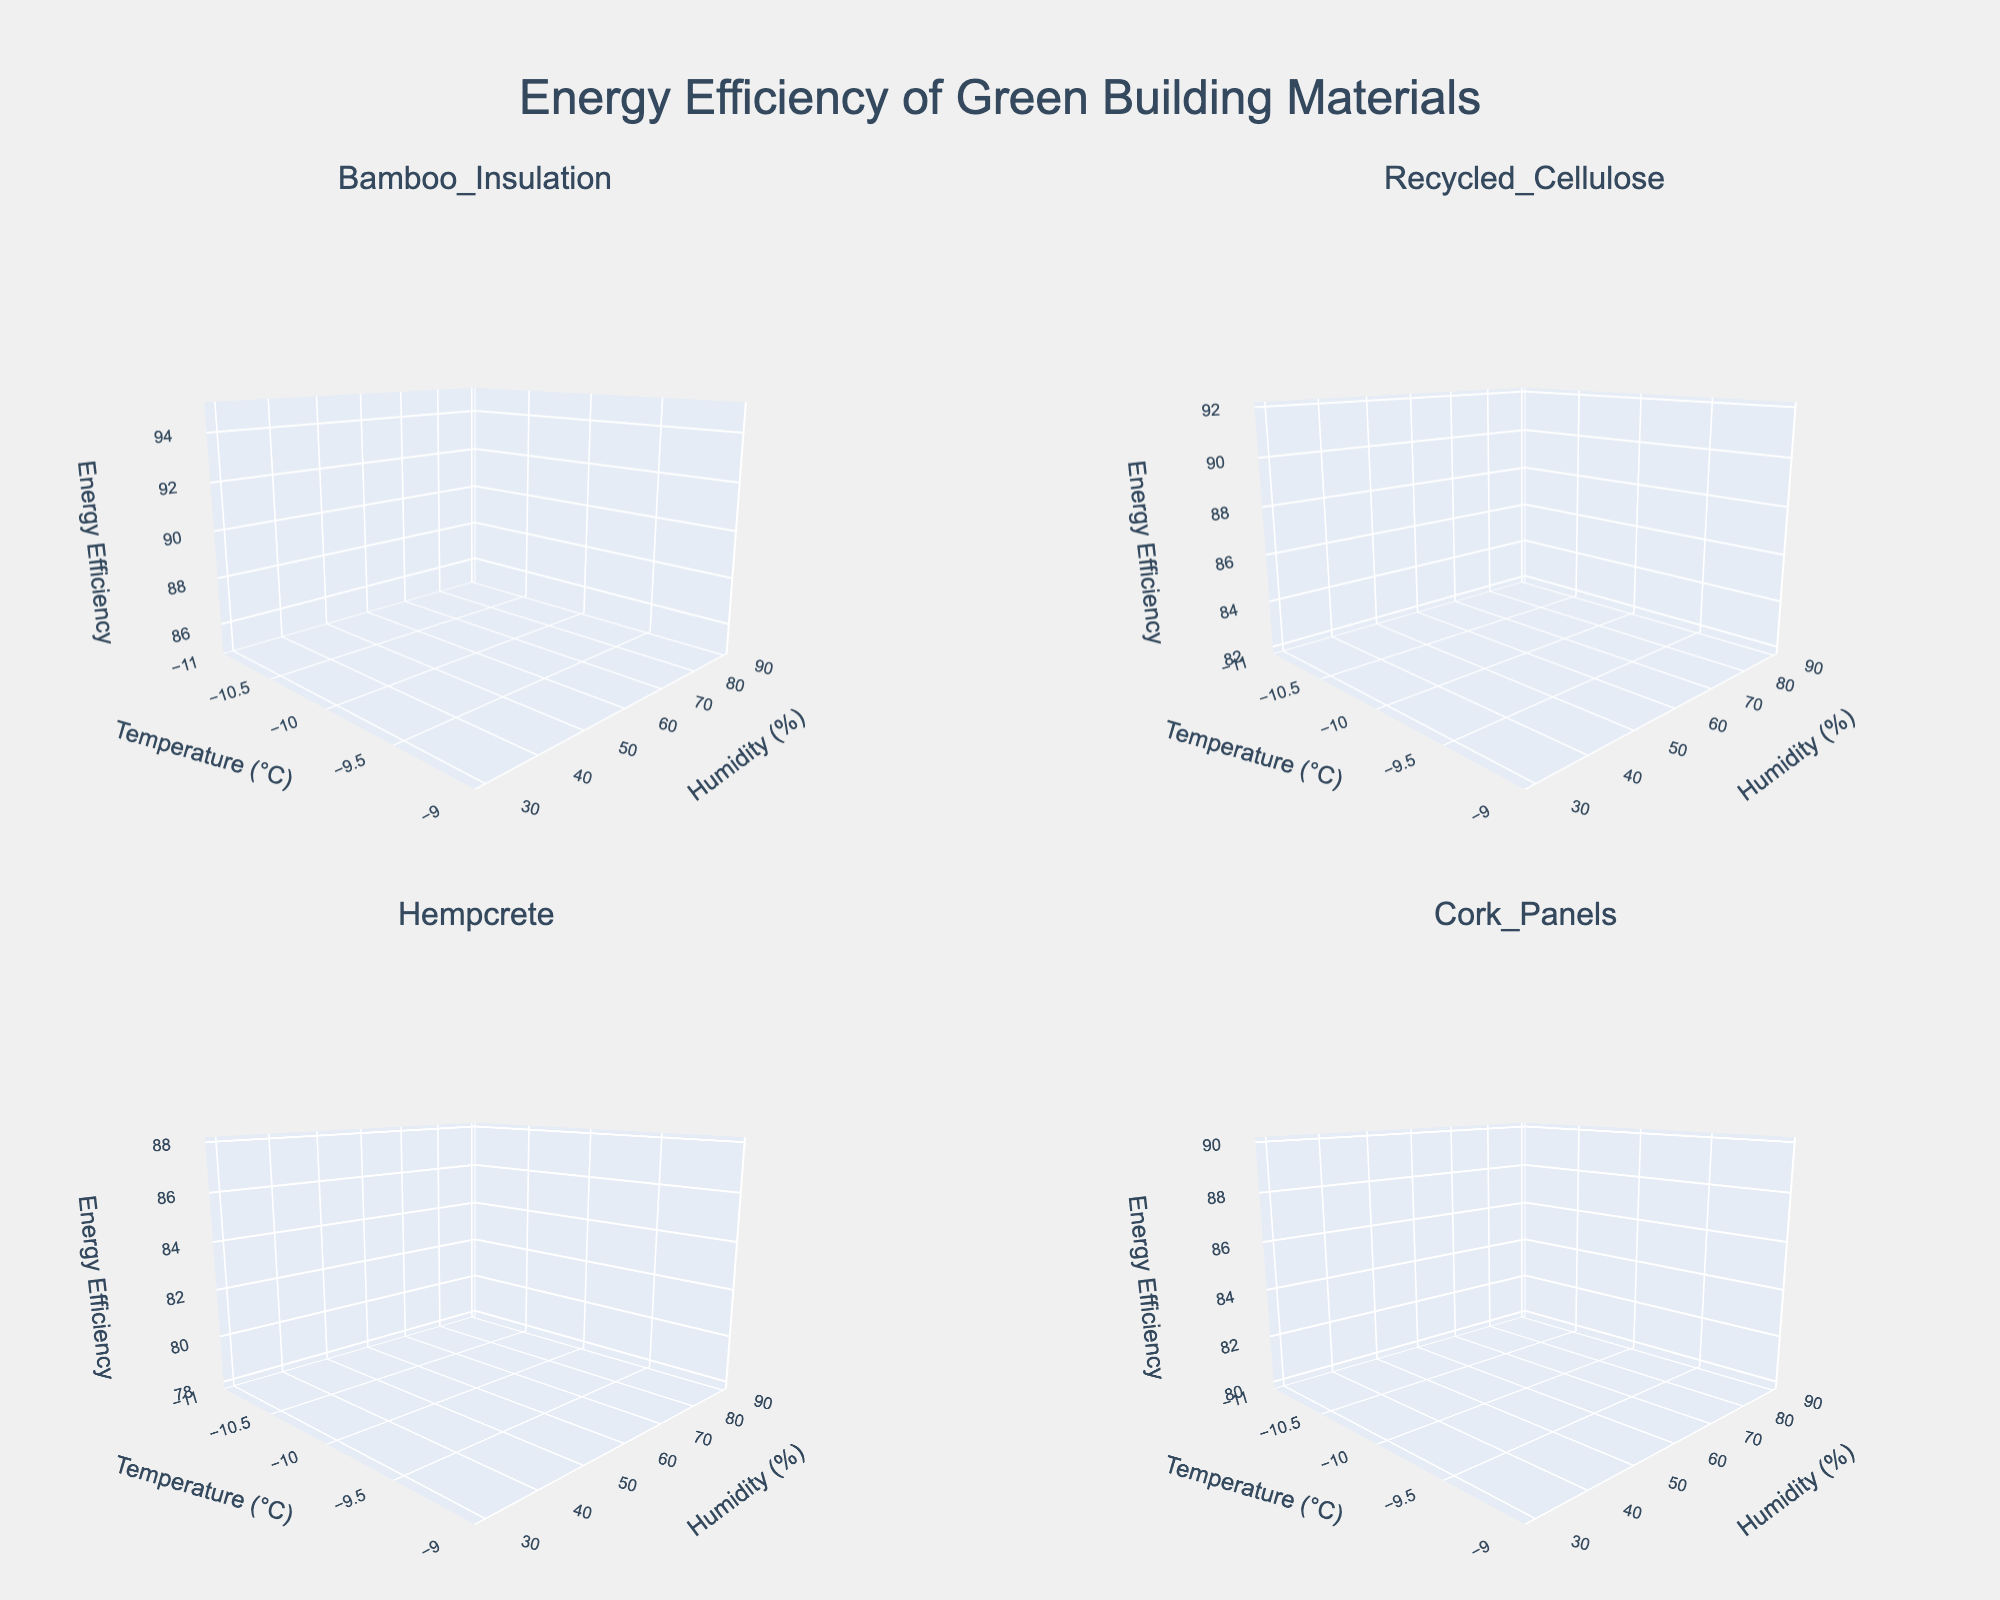What is the title of the figure? The title is typically displayed at the top of a figure and summarizes the main focus of the visualization. According to the code, the title of the figure is "Energy Efficiency of Green Building Materials."
Answer: Energy Efficiency of Green Building Materials Which material shows the highest energy efficiency at 20°C and 30% humidity? First, look at the subplot titles to locate the subplot for each material. Then, find the energy efficiency values at 20°C and 30% humidity. Bamboo Insulation has the highest energy efficiency at this condition, registering 95 in its subplot.
Answer: Bamboo Insulation How does the energy efficiency of Recycled Cellulose change as humidity increases from 30% to 90% at 20°C? Examine the subplot for Recycled Cellulose to determine the energy efficiency at various humidity levels. The values are 92, 89, 86, and 83 as humidity increases from 30% to 90%.
Answer: Decreases Compare the energy efficiency of Hempcrete and Cork Panels at 20°C and 50% humidity. Which is more efficient? Locate the subplots for Hempcrete and Cork Panels and find the energy efficiency values at 20°C and 50% humidity. Both materials have the same energy efficiency of 86 at this condition.
Answer: Both are equal Which subplots show a decline in energy efficiency as the temperature increases from 20°C to 30°C at 30% humidity? Check each subplot for the values at 20°C and 30°C and 30% humidity. Bamboo Insulation and Hempcrete both decline (95 to 93 and 88 to 86, respectively).
Answer: Bamboo Insulation and Hempcrete If we average the energy efficiency values at -10°C across all humidity levels, which material is most efficient? Identify the energy efficiency values at -10°C for each humidity level in each subplot. For Bamboo Insulation (-10°C: 85), Recycled Cellulose (-10°C: 82), Hempcrete (-10°C: 78), and Cork Panels (-10°C: 80). Calculate the averages; Bamboo Insulation has the highest value.
Answer: Bamboo Insulation What trend is observed in Cork Panels' energy efficiency as temperature increases from -10°C to 20°C at 30% humidity? Follow Cork Panels' energy efficiency values at 30% humidity as temperature increases (-10°C: 80, 0°C: 83, 10°C: 87, 20°C: 90). The trend observed is an increase.
Answer: Increases Is there a material that shows a consistent energy efficiency of 86 at two different humidity levels? Check each subplot for duplicate energy efficiency values of 86 with different humidity levels. Hempcrete shows an energy efficiency of 86 at 20°C for both 50% and 90% humidity levels.
Answer: Hempcrete For Recycled Cellulose, how does energy efficiency change as temperate increases from -10°C to 30°C at 30% humidity? Monitor the energy efficiency in the subplot for Recycled Cellulose at 30% humidity through the temperature range. The values are 82, 85, 89, 92, and 90. The efficiency initially increases and then slightly decreases.
Answer: Increases then decreases 